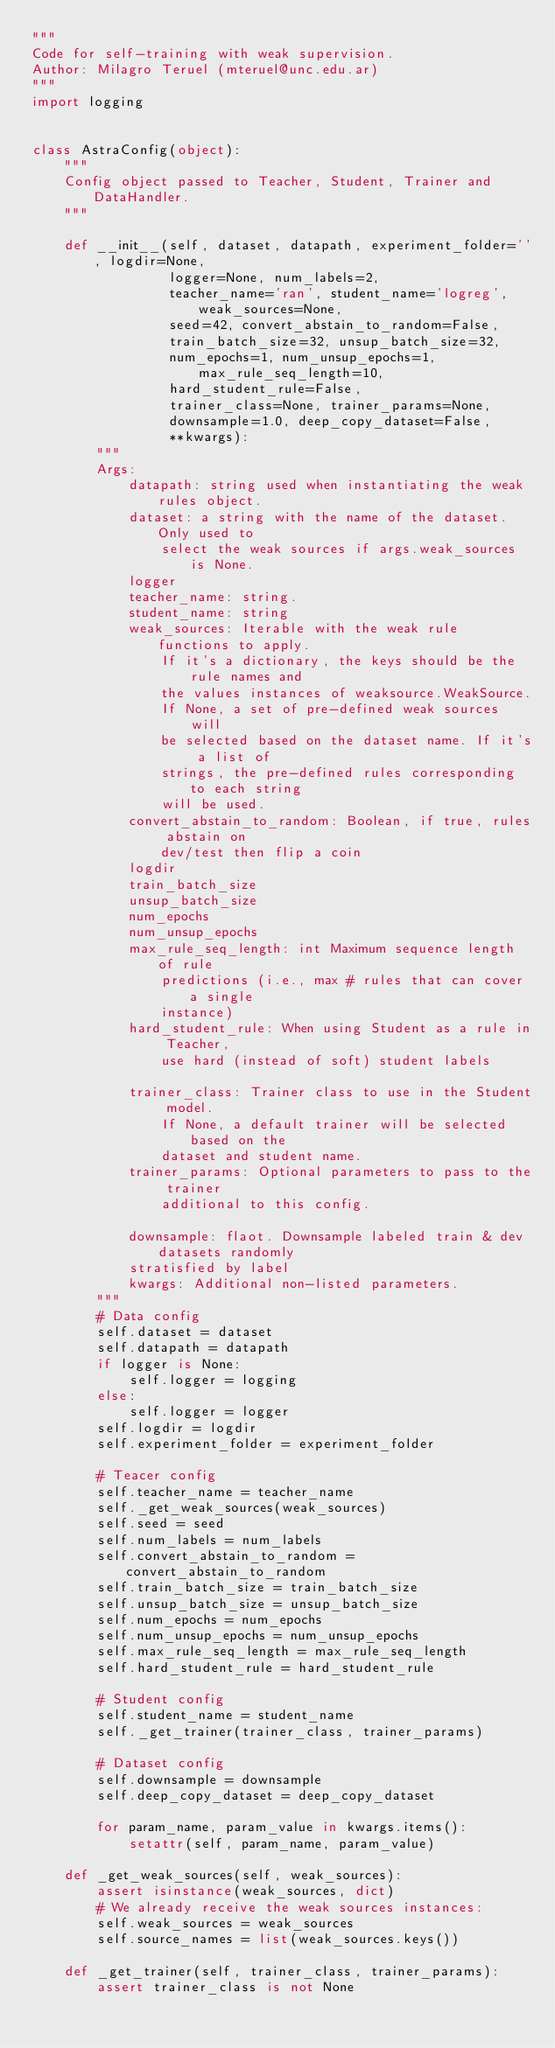Convert code to text. <code><loc_0><loc_0><loc_500><loc_500><_Python_>"""
Code for self-training with weak supervision.
Author: Milagro Teruel (mteruel@unc.edu.ar)
"""
import logging


class AstraConfig(object):
    """
    Config object passed to Teacher, Student, Trainer and DataHandler.
    """

    def __init__(self, dataset, datapath, experiment_folder='', logdir=None,
                 logger=None, num_labels=2,
                 teacher_name='ran', student_name='logreg', weak_sources=None,
                 seed=42, convert_abstain_to_random=False,
                 train_batch_size=32, unsup_batch_size=32,
                 num_epochs=1, num_unsup_epochs=1, max_rule_seq_length=10,
                 hard_student_rule=False,
                 trainer_class=None, trainer_params=None,
                 downsample=1.0, deep_copy_dataset=False,
                 **kwargs):
        """
        Args:
            datapath: string used when instantiating the weak rules object.
            dataset: a string with the name of the dataset. Only used to
                select the weak sources if args.weak_sources is None.
            logger
            teacher_name: string.
            student_name: string
            weak_sources: Iterable with the weak rule functions to apply.
                If it's a dictionary, the keys should be the rule names and
                the values instances of weaksource.WeakSource.
                If None, a set of pre-defined weak sources will
                be selected based on the dataset name. If it's a list of
                strings, the pre-defined rules corresponding to each string
                will be used.
            convert_abstain_to_random: Boolean, if true, rules abstain on
                dev/test then flip a coin
            logdir
            train_batch_size
            unsup_batch_size
            num_epochs
            num_unsup_epochs
            max_rule_seq_length: int Maximum sequence length of rule
                predictions (i.e., max # rules that can cover a single
                instance)
            hard_student_rule: When using Student as a rule in Teacher,
                use hard (instead of soft) student labels

            trainer_class: Trainer class to use in the Student model.
                If None, a default trainer will be selected based on the
                dataset and student name.
            trainer_params: Optional parameters to pass to the trainer
                additional to this config.

            downsample: flaot. Downsample labeled train & dev datasets randomly
            stratisfied by label
            kwargs: Additional non-listed parameters.
        """
        # Data config
        self.dataset = dataset
        self.datapath = datapath
        if logger is None:
            self.logger = logging
        else:
            self.logger = logger
        self.logdir = logdir
        self.experiment_folder = experiment_folder

        # Teacer config
        self.teacher_name = teacher_name
        self._get_weak_sources(weak_sources)
        self.seed = seed
        self.num_labels = num_labels
        self.convert_abstain_to_random = convert_abstain_to_random
        self.train_batch_size = train_batch_size
        self.unsup_batch_size = unsup_batch_size
        self.num_epochs = num_epochs
        self.num_unsup_epochs = num_unsup_epochs
        self.max_rule_seq_length = max_rule_seq_length
        self.hard_student_rule = hard_student_rule

        # Student config
        self.student_name = student_name
        self._get_trainer(trainer_class, trainer_params)

        # Dataset config
        self.downsample = downsample
        self.deep_copy_dataset = deep_copy_dataset

        for param_name, param_value in kwargs.items():
            setattr(self, param_name, param_value)

    def _get_weak_sources(self, weak_sources):
        assert isinstance(weak_sources, dict)
        # We already receive the weak sources instances:
        self.weak_sources = weak_sources
        self.source_names = list(weak_sources.keys())

    def _get_trainer(self, trainer_class, trainer_params):
        assert trainer_class is not None</code> 